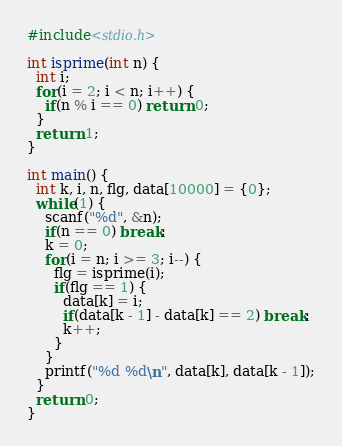Convert code to text. <code><loc_0><loc_0><loc_500><loc_500><_C_>#include<stdio.h>

int isprime(int n) {
  int i;
  for(i = 2; i < n; i++) {
    if(n % i == 0) return 0;
  }
  return 1;
}

int main() {
  int k, i, n, flg, data[10000] = {0};
  while(1) {
    scanf("%d", &n);
    if(n == 0) break;
    k = 0;
    for(i = n; i >= 3; i--) {
      flg = isprime(i);
      if(flg == 1) {
        data[k] = i;
        if(data[k - 1] - data[k] == 2) break;
        k++;
      }
    }
    printf("%d %d\n", data[k], data[k - 1]);
  }
  return 0;
}</code> 